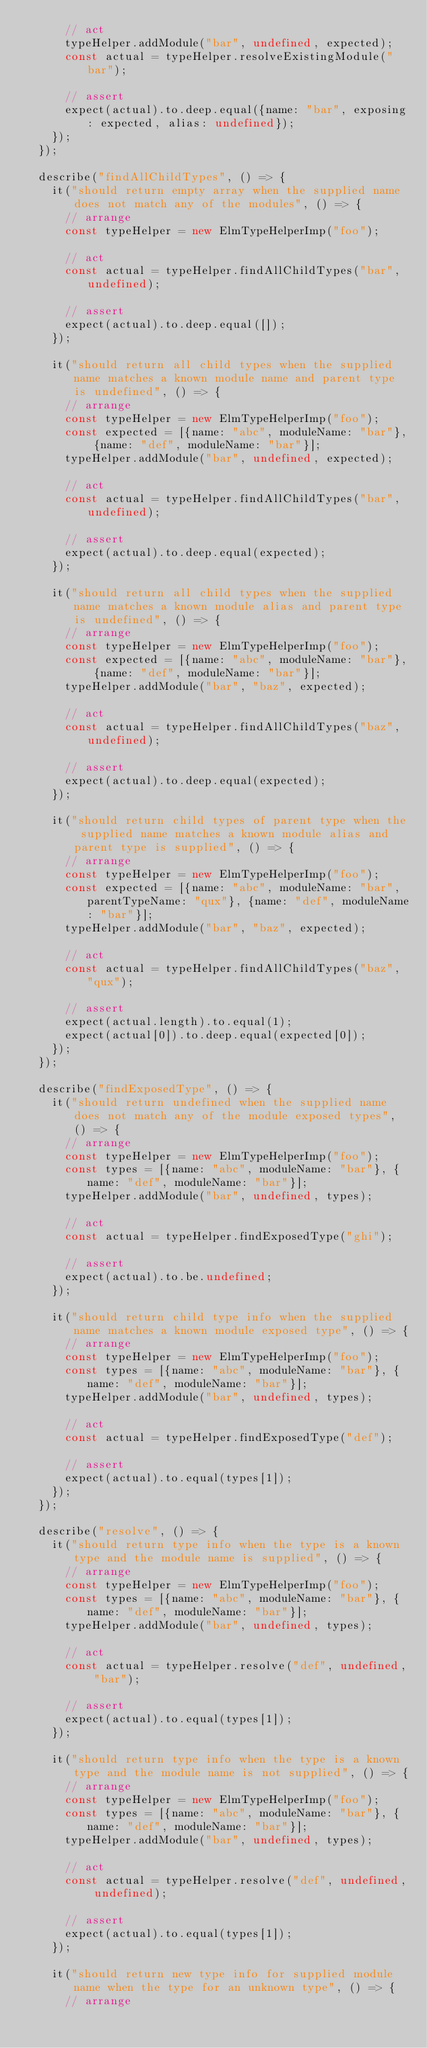<code> <loc_0><loc_0><loc_500><loc_500><_TypeScript_>      // act
      typeHelper.addModule("bar", undefined, expected);
      const actual = typeHelper.resolveExistingModule("bar");

      // assert
      expect(actual).to.deep.equal({name: "bar", exposing: expected, alias: undefined});
    });
  });

  describe("findAllChildTypes", () => {
    it("should return empty array when the supplied name does not match any of the modules", () => {
      // arrange
      const typeHelper = new ElmTypeHelperImp("foo");

      // act
      const actual = typeHelper.findAllChildTypes("bar", undefined);

      // assert
      expect(actual).to.deep.equal([]);
    });

    it("should return all child types when the supplied name matches a known module name and parent type is undefined", () => {
      // arrange
      const typeHelper = new ElmTypeHelperImp("foo");
      const expected = [{name: "abc", moduleName: "bar"}, {name: "def", moduleName: "bar"}];
      typeHelper.addModule("bar", undefined, expected);

      // act
      const actual = typeHelper.findAllChildTypes("bar", undefined);

      // assert
      expect(actual).to.deep.equal(expected);
    });

    it("should return all child types when the supplied name matches a known module alias and parent type is undefined", () => {
      // arrange
      const typeHelper = new ElmTypeHelperImp("foo");
      const expected = [{name: "abc", moduleName: "bar"}, {name: "def", moduleName: "bar"}];
      typeHelper.addModule("bar", "baz", expected);

      // act
      const actual = typeHelper.findAllChildTypes("baz", undefined);

      // assert
      expect(actual).to.deep.equal(expected);
    });

    it("should return child types of parent type when the supplied name matches a known module alias and parent type is supplied", () => {
      // arrange
      const typeHelper = new ElmTypeHelperImp("foo");
      const expected = [{name: "abc", moduleName: "bar", parentTypeName: "qux"}, {name: "def", moduleName: "bar"}];
      typeHelper.addModule("bar", "baz", expected);

      // act
      const actual = typeHelper.findAllChildTypes("baz", "qux");

      // assert
      expect(actual.length).to.equal(1);
      expect(actual[0]).to.deep.equal(expected[0]);
    });
  });

  describe("findExposedType", () => {
    it("should return undefined when the supplied name does not match any of the module exposed types", () => {
      // arrange
      const typeHelper = new ElmTypeHelperImp("foo");
      const types = [{name: "abc", moduleName: "bar"}, {name: "def", moduleName: "bar"}];
      typeHelper.addModule("bar", undefined, types);

      // act
      const actual = typeHelper.findExposedType("ghi");

      // assert
      expect(actual).to.be.undefined;
    });

    it("should return child type info when the supplied name matches a known module exposed type", () => {
      // arrange
      const typeHelper = new ElmTypeHelperImp("foo");
      const types = [{name: "abc", moduleName: "bar"}, {name: "def", moduleName: "bar"}];
      typeHelper.addModule("bar", undefined, types);

      // act
      const actual = typeHelper.findExposedType("def");

      // assert
      expect(actual).to.equal(types[1]);
    });
  });

  describe("resolve", () => {
    it("should return type info when the type is a known type and the module name is supplied", () => {
      // arrange
      const typeHelper = new ElmTypeHelperImp("foo");
      const types = [{name: "abc", moduleName: "bar"}, {name: "def", moduleName: "bar"}];
      typeHelper.addModule("bar", undefined, types);

      // act
      const actual = typeHelper.resolve("def", undefined, "bar");

      // assert
      expect(actual).to.equal(types[1]);
    });

    it("should return type info when the type is a known type and the module name is not supplied", () => {
      // arrange
      const typeHelper = new ElmTypeHelperImp("foo");
      const types = [{name: "abc", moduleName: "bar"}, {name: "def", moduleName: "bar"}];
      typeHelper.addModule("bar", undefined, types);

      // act
      const actual = typeHelper.resolve("def", undefined, undefined);

      // assert
      expect(actual).to.equal(types[1]);
    });

    it("should return new type info for supplied module name when the type for an unknown type", () => {
      // arrange</code> 